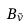Convert formula to latex. <formula><loc_0><loc_0><loc_500><loc_500>B _ { \tilde { \nu } }</formula> 